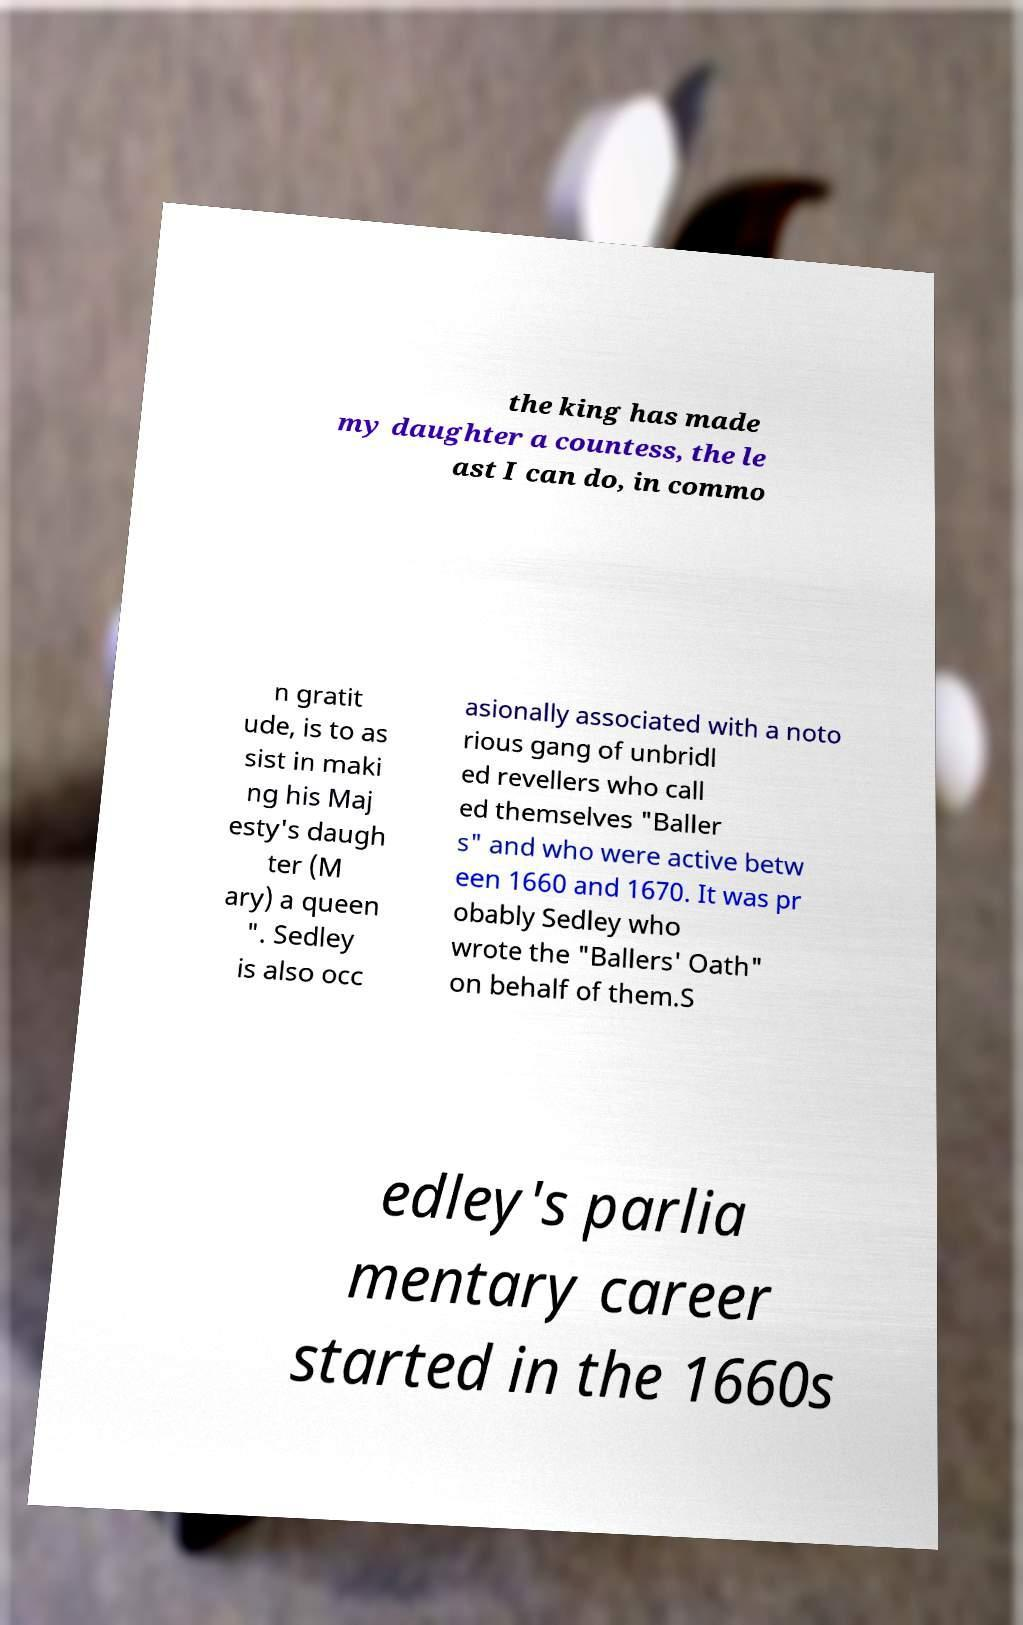I need the written content from this picture converted into text. Can you do that? the king has made my daughter a countess, the le ast I can do, in commo n gratit ude, is to as sist in maki ng his Maj esty's daugh ter (M ary) a queen ". Sedley is also occ asionally associated with a noto rious gang of unbridl ed revellers who call ed themselves "Baller s" and who were active betw een 1660 and 1670. It was pr obably Sedley who wrote the "Ballers' Oath" on behalf of them.S edley's parlia mentary career started in the 1660s 